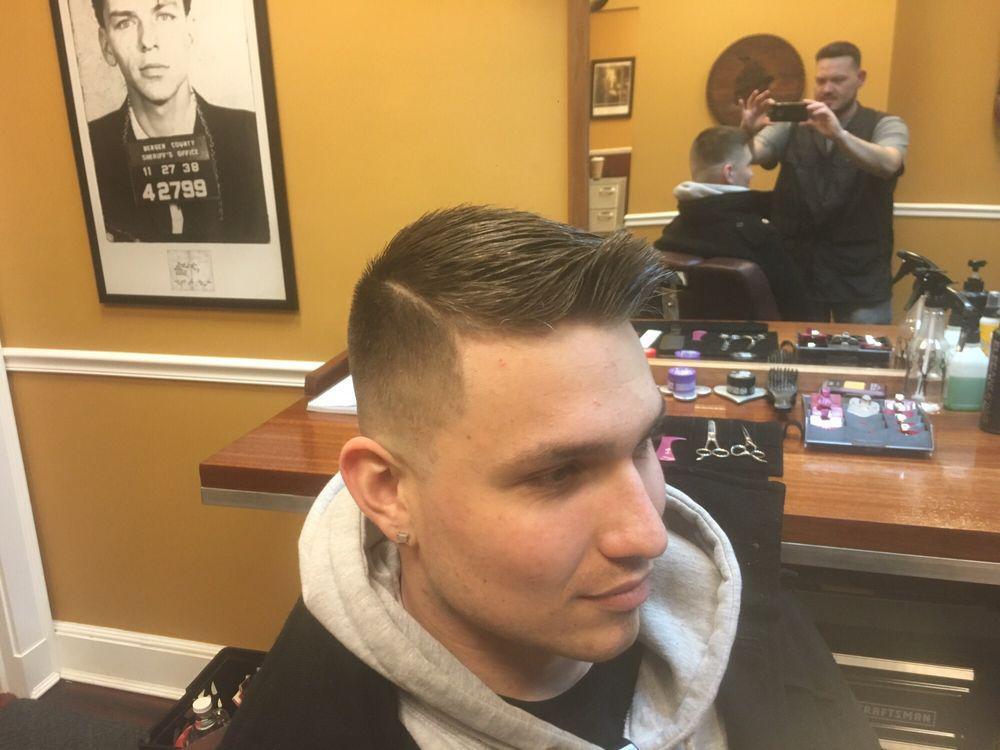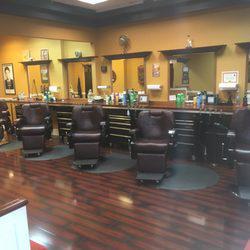The first image is the image on the left, the second image is the image on the right. Given the left and right images, does the statement "There is at least one empty chair shown." hold true? Answer yes or no. Yes. 